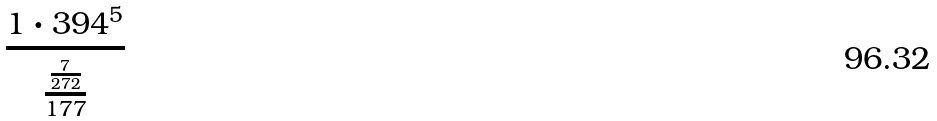Convert formula to latex. <formula><loc_0><loc_0><loc_500><loc_500>\frac { 1 \cdot 3 9 4 ^ { 5 } } { \frac { \frac { 7 } { 2 7 2 } } { 1 7 7 } }</formula> 